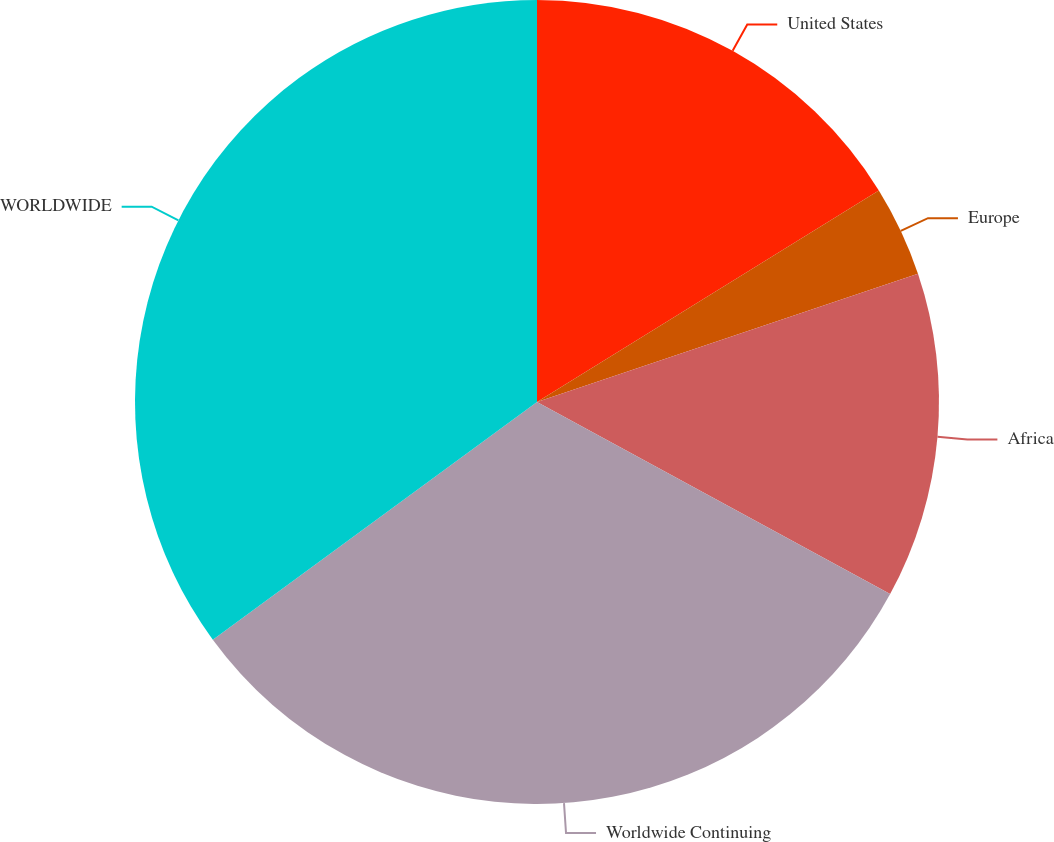Convert chart to OTSL. <chart><loc_0><loc_0><loc_500><loc_500><pie_chart><fcel>United States<fcel>Europe<fcel>Africa<fcel>Worldwide Continuing<fcel>WORLDWIDE<nl><fcel>16.18%<fcel>3.65%<fcel>13.1%<fcel>32.0%<fcel>35.07%<nl></chart> 